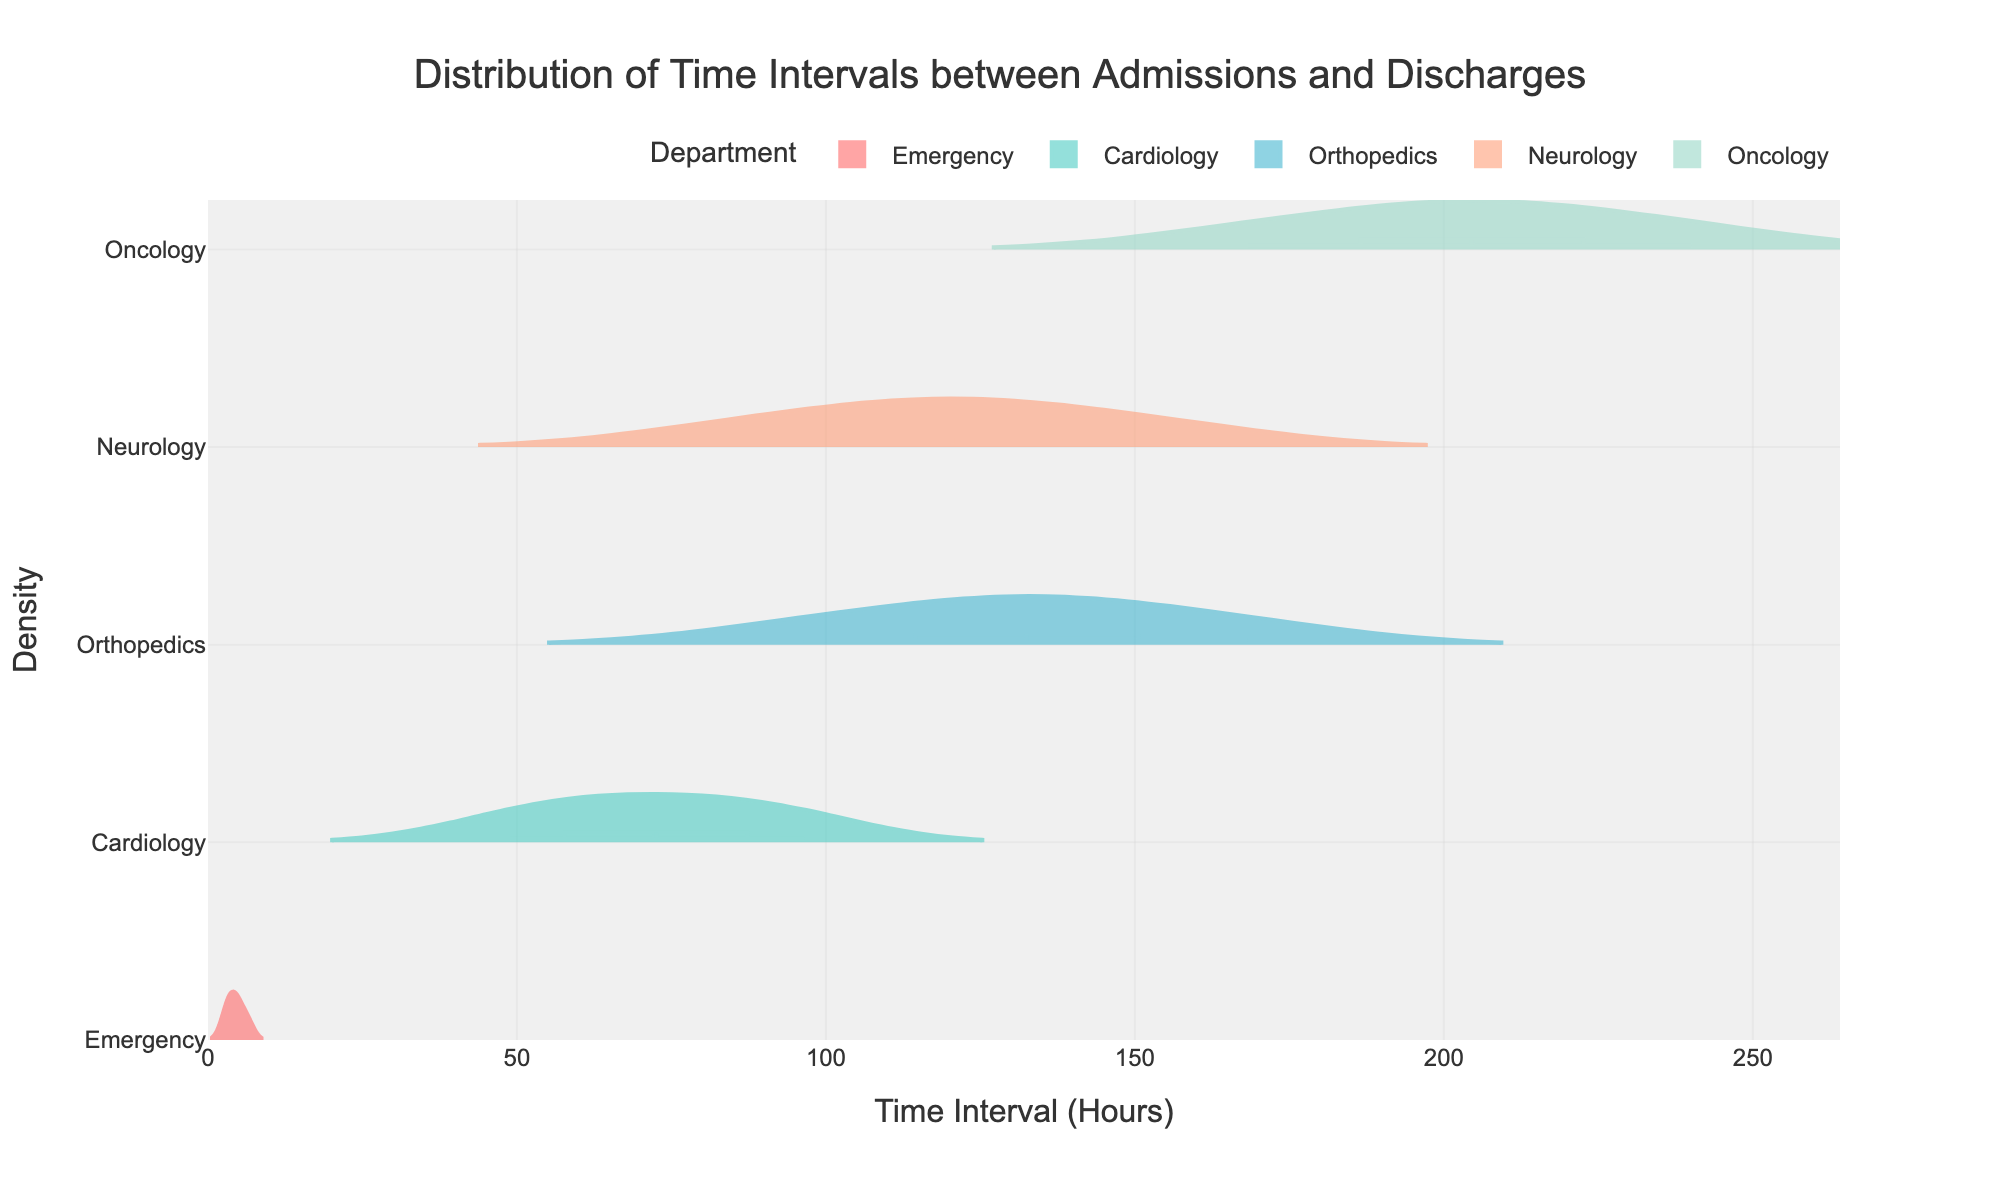What is the title of the figure? The title of the figure is displayed at the top and is meant to describe what the figure is about.
Answer: Distribution of Time Intervals between Admissions and Discharges What departments are represented in the figure? The figure displays different density plots for multiple departments, each labeled accordingly.
Answer: Emergency, Cardiology, Orthopedics, Neurology, Oncology Which department has the longest average time interval between admissions and discharges? Average time can be determined by observing the mean lines on the density plots. The one with the furthest right mean line has the longest average time interval.
Answer: Oncology How does the time interval in the Emergency department generally compare to the Cardiology department? Compare the positions and spreads of the density plots for Emergency and Cardiology. The Emergency department has a much shorter time interval while Cardiology spans over a much wider range of higher values.
Answer: Emergency is much shorter than Cardiology Which department has the widest spread of time intervals? The width of the density plot indicates the spread of the data. The one which stretches the furthest along the x-axis has the widest spread.
Answer: Orthopedics Among all departments, which one has the shortest admission to discharge interval? Identify the density plot that starts closest to the zero on the x-axis.
Answer: Emergency In the Oncology department, what is the approximate range of time intervals observed? Observe the extent of the density plot for Oncology on the x-axis to determine the lower and upper bounds.
Answer: Approximately 168 to 240 hours What can be inferred about time intervals in Neurology compared to Orthopedics? Look at the density plots for both Neurology and Orthopedics. Neurology’s plot starts at a lower time interval and has a narrower spread compared to Orthopedics.
Answer: Neurology has generally shorter and less varied intervals compared to Orthopedics Which department has the mean time interval closest to 100 hours? Check the mean lines on the density plots. The mean line closest to the 100-hour mark on the x-axis indicates the department.
Answer: Cardiology 